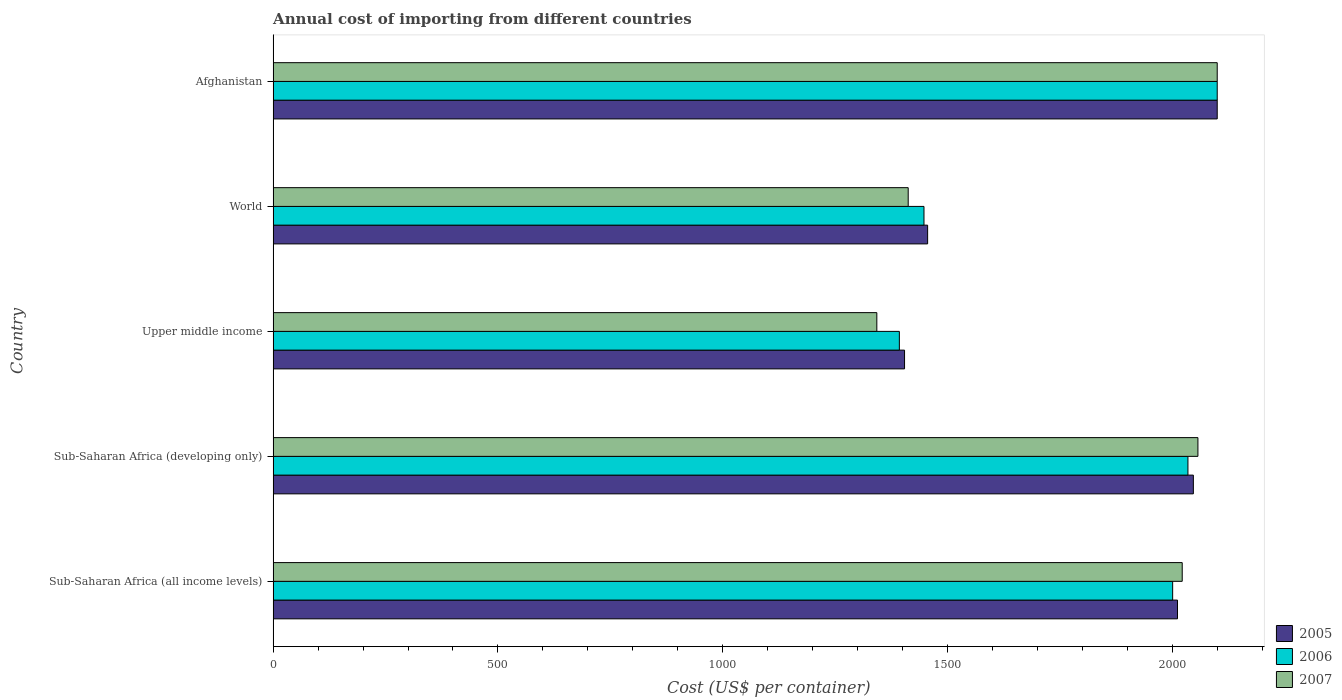How many different coloured bars are there?
Provide a short and direct response. 3. How many bars are there on the 2nd tick from the bottom?
Give a very brief answer. 3. What is the label of the 5th group of bars from the top?
Your answer should be compact. Sub-Saharan Africa (all income levels). In how many cases, is the number of bars for a given country not equal to the number of legend labels?
Keep it short and to the point. 0. What is the total annual cost of importing in 2006 in Sub-Saharan Africa (all income levels)?
Give a very brief answer. 2000.87. Across all countries, what is the maximum total annual cost of importing in 2006?
Make the answer very short. 2100. Across all countries, what is the minimum total annual cost of importing in 2007?
Offer a terse response. 1342.85. In which country was the total annual cost of importing in 2006 maximum?
Your answer should be compact. Afghanistan. In which country was the total annual cost of importing in 2006 minimum?
Offer a terse response. Upper middle income. What is the total total annual cost of importing in 2007 in the graph?
Give a very brief answer. 8934.67. What is the difference between the total annual cost of importing in 2005 in Sub-Saharan Africa (developing only) and that in Upper middle income?
Give a very brief answer. 642.4. What is the difference between the total annual cost of importing in 2006 in Sub-Saharan Africa (developing only) and the total annual cost of importing in 2005 in Sub-Saharan Africa (all income levels)?
Make the answer very short. 23.2. What is the average total annual cost of importing in 2006 per country?
Ensure brevity in your answer.  1795.28. What is the difference between the total annual cost of importing in 2007 and total annual cost of importing in 2006 in Sub-Saharan Africa (all income levels)?
Offer a very short reply. 21.26. What is the ratio of the total annual cost of importing in 2006 in Afghanistan to that in World?
Your answer should be compact. 1.45. What is the difference between the highest and the second highest total annual cost of importing in 2007?
Keep it short and to the point. 42.93. What is the difference between the highest and the lowest total annual cost of importing in 2005?
Offer a terse response. 695.49. Is the sum of the total annual cost of importing in 2006 in Sub-Saharan Africa (developing only) and Upper middle income greater than the maximum total annual cost of importing in 2007 across all countries?
Offer a terse response. Yes. Is it the case that in every country, the sum of the total annual cost of importing in 2007 and total annual cost of importing in 2006 is greater than the total annual cost of importing in 2005?
Provide a succinct answer. Yes. Are all the bars in the graph horizontal?
Provide a succinct answer. Yes. How many countries are there in the graph?
Offer a terse response. 5. Does the graph contain any zero values?
Offer a very short reply. No. Does the graph contain grids?
Provide a succinct answer. No. How many legend labels are there?
Your response must be concise. 3. What is the title of the graph?
Your answer should be very brief. Annual cost of importing from different countries. Does "2002" appear as one of the legend labels in the graph?
Provide a succinct answer. No. What is the label or title of the X-axis?
Give a very brief answer. Cost (US$ per container). What is the Cost (US$ per container) of 2005 in Sub-Saharan Africa (all income levels)?
Keep it short and to the point. 2011.64. What is the Cost (US$ per container) of 2006 in Sub-Saharan Africa (all income levels)?
Provide a succinct answer. 2000.87. What is the Cost (US$ per container) in 2007 in Sub-Saharan Africa (all income levels)?
Make the answer very short. 2022.13. What is the Cost (US$ per container) in 2005 in Sub-Saharan Africa (developing only)?
Your answer should be compact. 2046.91. What is the Cost (US$ per container) in 2006 in Sub-Saharan Africa (developing only)?
Provide a succinct answer. 2034.84. What is the Cost (US$ per container) of 2007 in Sub-Saharan Africa (developing only)?
Provide a short and direct response. 2057.07. What is the Cost (US$ per container) in 2005 in Upper middle income?
Your answer should be compact. 1404.51. What is the Cost (US$ per container) of 2006 in Upper middle income?
Ensure brevity in your answer.  1392.96. What is the Cost (US$ per container) of 2007 in Upper middle income?
Offer a terse response. 1342.85. What is the Cost (US$ per container) in 2005 in World?
Your answer should be compact. 1455.85. What is the Cost (US$ per container) of 2006 in World?
Provide a short and direct response. 1447.74. What is the Cost (US$ per container) of 2007 in World?
Make the answer very short. 1412.62. What is the Cost (US$ per container) of 2005 in Afghanistan?
Offer a very short reply. 2100. What is the Cost (US$ per container) in 2006 in Afghanistan?
Provide a short and direct response. 2100. What is the Cost (US$ per container) of 2007 in Afghanistan?
Provide a short and direct response. 2100. Across all countries, what is the maximum Cost (US$ per container) of 2005?
Make the answer very short. 2100. Across all countries, what is the maximum Cost (US$ per container) in 2006?
Make the answer very short. 2100. Across all countries, what is the maximum Cost (US$ per container) in 2007?
Keep it short and to the point. 2100. Across all countries, what is the minimum Cost (US$ per container) in 2005?
Offer a very short reply. 1404.51. Across all countries, what is the minimum Cost (US$ per container) of 2006?
Ensure brevity in your answer.  1392.96. Across all countries, what is the minimum Cost (US$ per container) of 2007?
Ensure brevity in your answer.  1342.85. What is the total Cost (US$ per container) of 2005 in the graph?
Make the answer very short. 9018.91. What is the total Cost (US$ per container) of 2006 in the graph?
Your answer should be very brief. 8976.41. What is the total Cost (US$ per container) of 2007 in the graph?
Ensure brevity in your answer.  8934.67. What is the difference between the Cost (US$ per container) of 2005 in Sub-Saharan Africa (all income levels) and that in Sub-Saharan Africa (developing only)?
Your response must be concise. -35.26. What is the difference between the Cost (US$ per container) of 2006 in Sub-Saharan Africa (all income levels) and that in Sub-Saharan Africa (developing only)?
Your answer should be very brief. -33.97. What is the difference between the Cost (US$ per container) in 2007 in Sub-Saharan Africa (all income levels) and that in Sub-Saharan Africa (developing only)?
Your response must be concise. -34.94. What is the difference between the Cost (US$ per container) in 2005 in Sub-Saharan Africa (all income levels) and that in Upper middle income?
Provide a succinct answer. 607.13. What is the difference between the Cost (US$ per container) in 2006 in Sub-Saharan Africa (all income levels) and that in Upper middle income?
Provide a succinct answer. 607.91. What is the difference between the Cost (US$ per container) of 2007 in Sub-Saharan Africa (all income levels) and that in Upper middle income?
Make the answer very short. 679.28. What is the difference between the Cost (US$ per container) in 2005 in Sub-Saharan Africa (all income levels) and that in World?
Your response must be concise. 555.79. What is the difference between the Cost (US$ per container) of 2006 in Sub-Saharan Africa (all income levels) and that in World?
Your answer should be compact. 553.13. What is the difference between the Cost (US$ per container) of 2007 in Sub-Saharan Africa (all income levels) and that in World?
Your answer should be compact. 609.51. What is the difference between the Cost (US$ per container) in 2005 in Sub-Saharan Africa (all income levels) and that in Afghanistan?
Give a very brief answer. -88.36. What is the difference between the Cost (US$ per container) of 2006 in Sub-Saharan Africa (all income levels) and that in Afghanistan?
Offer a terse response. -99.13. What is the difference between the Cost (US$ per container) in 2007 in Sub-Saharan Africa (all income levels) and that in Afghanistan?
Keep it short and to the point. -77.87. What is the difference between the Cost (US$ per container) of 2005 in Sub-Saharan Africa (developing only) and that in Upper middle income?
Keep it short and to the point. 642.4. What is the difference between the Cost (US$ per container) of 2006 in Sub-Saharan Africa (developing only) and that in Upper middle income?
Offer a terse response. 641.88. What is the difference between the Cost (US$ per container) of 2007 in Sub-Saharan Africa (developing only) and that in Upper middle income?
Keep it short and to the point. 714.21. What is the difference between the Cost (US$ per container) in 2005 in Sub-Saharan Africa (developing only) and that in World?
Provide a short and direct response. 591.06. What is the difference between the Cost (US$ per container) of 2006 in Sub-Saharan Africa (developing only) and that in World?
Keep it short and to the point. 587.1. What is the difference between the Cost (US$ per container) of 2007 in Sub-Saharan Africa (developing only) and that in World?
Offer a very short reply. 644.45. What is the difference between the Cost (US$ per container) of 2005 in Sub-Saharan Africa (developing only) and that in Afghanistan?
Offer a terse response. -53.09. What is the difference between the Cost (US$ per container) in 2006 in Sub-Saharan Africa (developing only) and that in Afghanistan?
Keep it short and to the point. -65.16. What is the difference between the Cost (US$ per container) of 2007 in Sub-Saharan Africa (developing only) and that in Afghanistan?
Offer a terse response. -42.93. What is the difference between the Cost (US$ per container) in 2005 in Upper middle income and that in World?
Ensure brevity in your answer.  -51.34. What is the difference between the Cost (US$ per container) in 2006 in Upper middle income and that in World?
Your answer should be very brief. -54.78. What is the difference between the Cost (US$ per container) of 2007 in Upper middle income and that in World?
Make the answer very short. -69.76. What is the difference between the Cost (US$ per container) of 2005 in Upper middle income and that in Afghanistan?
Offer a very short reply. -695.49. What is the difference between the Cost (US$ per container) in 2006 in Upper middle income and that in Afghanistan?
Offer a very short reply. -707.04. What is the difference between the Cost (US$ per container) in 2007 in Upper middle income and that in Afghanistan?
Your answer should be very brief. -757.15. What is the difference between the Cost (US$ per container) in 2005 in World and that in Afghanistan?
Your answer should be compact. -644.15. What is the difference between the Cost (US$ per container) of 2006 in World and that in Afghanistan?
Provide a short and direct response. -652.26. What is the difference between the Cost (US$ per container) of 2007 in World and that in Afghanistan?
Ensure brevity in your answer.  -687.38. What is the difference between the Cost (US$ per container) of 2005 in Sub-Saharan Africa (all income levels) and the Cost (US$ per container) of 2006 in Sub-Saharan Africa (developing only)?
Your answer should be very brief. -23.2. What is the difference between the Cost (US$ per container) of 2005 in Sub-Saharan Africa (all income levels) and the Cost (US$ per container) of 2007 in Sub-Saharan Africa (developing only)?
Your answer should be compact. -45.42. What is the difference between the Cost (US$ per container) in 2006 in Sub-Saharan Africa (all income levels) and the Cost (US$ per container) in 2007 in Sub-Saharan Africa (developing only)?
Offer a terse response. -56.2. What is the difference between the Cost (US$ per container) in 2005 in Sub-Saharan Africa (all income levels) and the Cost (US$ per container) in 2006 in Upper middle income?
Your answer should be compact. 618.69. What is the difference between the Cost (US$ per container) of 2005 in Sub-Saharan Africa (all income levels) and the Cost (US$ per container) of 2007 in Upper middle income?
Keep it short and to the point. 668.79. What is the difference between the Cost (US$ per container) in 2006 in Sub-Saharan Africa (all income levels) and the Cost (US$ per container) in 2007 in Upper middle income?
Give a very brief answer. 658.02. What is the difference between the Cost (US$ per container) in 2005 in Sub-Saharan Africa (all income levels) and the Cost (US$ per container) in 2006 in World?
Keep it short and to the point. 563.9. What is the difference between the Cost (US$ per container) in 2005 in Sub-Saharan Africa (all income levels) and the Cost (US$ per container) in 2007 in World?
Offer a very short reply. 599.03. What is the difference between the Cost (US$ per container) of 2006 in Sub-Saharan Africa (all income levels) and the Cost (US$ per container) of 2007 in World?
Your answer should be very brief. 588.25. What is the difference between the Cost (US$ per container) of 2005 in Sub-Saharan Africa (all income levels) and the Cost (US$ per container) of 2006 in Afghanistan?
Make the answer very short. -88.36. What is the difference between the Cost (US$ per container) in 2005 in Sub-Saharan Africa (all income levels) and the Cost (US$ per container) in 2007 in Afghanistan?
Give a very brief answer. -88.36. What is the difference between the Cost (US$ per container) of 2006 in Sub-Saharan Africa (all income levels) and the Cost (US$ per container) of 2007 in Afghanistan?
Provide a short and direct response. -99.13. What is the difference between the Cost (US$ per container) of 2005 in Sub-Saharan Africa (developing only) and the Cost (US$ per container) of 2006 in Upper middle income?
Your response must be concise. 653.95. What is the difference between the Cost (US$ per container) in 2005 in Sub-Saharan Africa (developing only) and the Cost (US$ per container) in 2007 in Upper middle income?
Keep it short and to the point. 704.05. What is the difference between the Cost (US$ per container) in 2006 in Sub-Saharan Africa (developing only) and the Cost (US$ per container) in 2007 in Upper middle income?
Provide a short and direct response. 691.99. What is the difference between the Cost (US$ per container) in 2005 in Sub-Saharan Africa (developing only) and the Cost (US$ per container) in 2006 in World?
Ensure brevity in your answer.  599.17. What is the difference between the Cost (US$ per container) of 2005 in Sub-Saharan Africa (developing only) and the Cost (US$ per container) of 2007 in World?
Make the answer very short. 634.29. What is the difference between the Cost (US$ per container) of 2006 in Sub-Saharan Africa (developing only) and the Cost (US$ per container) of 2007 in World?
Give a very brief answer. 622.22. What is the difference between the Cost (US$ per container) in 2005 in Sub-Saharan Africa (developing only) and the Cost (US$ per container) in 2006 in Afghanistan?
Your answer should be compact. -53.09. What is the difference between the Cost (US$ per container) in 2005 in Sub-Saharan Africa (developing only) and the Cost (US$ per container) in 2007 in Afghanistan?
Make the answer very short. -53.09. What is the difference between the Cost (US$ per container) of 2006 in Sub-Saharan Africa (developing only) and the Cost (US$ per container) of 2007 in Afghanistan?
Provide a short and direct response. -65.16. What is the difference between the Cost (US$ per container) of 2005 in Upper middle income and the Cost (US$ per container) of 2006 in World?
Your answer should be very brief. -43.23. What is the difference between the Cost (US$ per container) of 2005 in Upper middle income and the Cost (US$ per container) of 2007 in World?
Give a very brief answer. -8.11. What is the difference between the Cost (US$ per container) in 2006 in Upper middle income and the Cost (US$ per container) in 2007 in World?
Offer a terse response. -19.66. What is the difference between the Cost (US$ per container) of 2005 in Upper middle income and the Cost (US$ per container) of 2006 in Afghanistan?
Provide a short and direct response. -695.49. What is the difference between the Cost (US$ per container) of 2005 in Upper middle income and the Cost (US$ per container) of 2007 in Afghanistan?
Give a very brief answer. -695.49. What is the difference between the Cost (US$ per container) of 2006 in Upper middle income and the Cost (US$ per container) of 2007 in Afghanistan?
Make the answer very short. -707.04. What is the difference between the Cost (US$ per container) in 2005 in World and the Cost (US$ per container) in 2006 in Afghanistan?
Make the answer very short. -644.15. What is the difference between the Cost (US$ per container) in 2005 in World and the Cost (US$ per container) in 2007 in Afghanistan?
Provide a succinct answer. -644.15. What is the difference between the Cost (US$ per container) in 2006 in World and the Cost (US$ per container) in 2007 in Afghanistan?
Provide a short and direct response. -652.26. What is the average Cost (US$ per container) of 2005 per country?
Provide a short and direct response. 1803.78. What is the average Cost (US$ per container) in 2006 per country?
Keep it short and to the point. 1795.28. What is the average Cost (US$ per container) of 2007 per country?
Offer a very short reply. 1786.93. What is the difference between the Cost (US$ per container) of 2005 and Cost (US$ per container) of 2006 in Sub-Saharan Africa (all income levels)?
Give a very brief answer. 10.77. What is the difference between the Cost (US$ per container) in 2005 and Cost (US$ per container) in 2007 in Sub-Saharan Africa (all income levels)?
Keep it short and to the point. -10.49. What is the difference between the Cost (US$ per container) in 2006 and Cost (US$ per container) in 2007 in Sub-Saharan Africa (all income levels)?
Provide a short and direct response. -21.26. What is the difference between the Cost (US$ per container) of 2005 and Cost (US$ per container) of 2006 in Sub-Saharan Africa (developing only)?
Give a very brief answer. 12.07. What is the difference between the Cost (US$ per container) of 2005 and Cost (US$ per container) of 2007 in Sub-Saharan Africa (developing only)?
Make the answer very short. -10.16. What is the difference between the Cost (US$ per container) of 2006 and Cost (US$ per container) of 2007 in Sub-Saharan Africa (developing only)?
Your answer should be compact. -22.23. What is the difference between the Cost (US$ per container) in 2005 and Cost (US$ per container) in 2006 in Upper middle income?
Your answer should be compact. 11.55. What is the difference between the Cost (US$ per container) of 2005 and Cost (US$ per container) of 2007 in Upper middle income?
Provide a short and direct response. 61.66. What is the difference between the Cost (US$ per container) of 2006 and Cost (US$ per container) of 2007 in Upper middle income?
Offer a terse response. 50.1. What is the difference between the Cost (US$ per container) of 2005 and Cost (US$ per container) of 2006 in World?
Ensure brevity in your answer.  8.11. What is the difference between the Cost (US$ per container) of 2005 and Cost (US$ per container) of 2007 in World?
Your answer should be compact. 43.23. What is the difference between the Cost (US$ per container) in 2006 and Cost (US$ per container) in 2007 in World?
Your answer should be very brief. 35.12. What is the ratio of the Cost (US$ per container) in 2005 in Sub-Saharan Africa (all income levels) to that in Sub-Saharan Africa (developing only)?
Offer a very short reply. 0.98. What is the ratio of the Cost (US$ per container) in 2006 in Sub-Saharan Africa (all income levels) to that in Sub-Saharan Africa (developing only)?
Your answer should be very brief. 0.98. What is the ratio of the Cost (US$ per container) in 2005 in Sub-Saharan Africa (all income levels) to that in Upper middle income?
Offer a terse response. 1.43. What is the ratio of the Cost (US$ per container) in 2006 in Sub-Saharan Africa (all income levels) to that in Upper middle income?
Ensure brevity in your answer.  1.44. What is the ratio of the Cost (US$ per container) of 2007 in Sub-Saharan Africa (all income levels) to that in Upper middle income?
Your answer should be compact. 1.51. What is the ratio of the Cost (US$ per container) in 2005 in Sub-Saharan Africa (all income levels) to that in World?
Your response must be concise. 1.38. What is the ratio of the Cost (US$ per container) in 2006 in Sub-Saharan Africa (all income levels) to that in World?
Your answer should be very brief. 1.38. What is the ratio of the Cost (US$ per container) of 2007 in Sub-Saharan Africa (all income levels) to that in World?
Offer a terse response. 1.43. What is the ratio of the Cost (US$ per container) in 2005 in Sub-Saharan Africa (all income levels) to that in Afghanistan?
Give a very brief answer. 0.96. What is the ratio of the Cost (US$ per container) of 2006 in Sub-Saharan Africa (all income levels) to that in Afghanistan?
Your response must be concise. 0.95. What is the ratio of the Cost (US$ per container) of 2007 in Sub-Saharan Africa (all income levels) to that in Afghanistan?
Give a very brief answer. 0.96. What is the ratio of the Cost (US$ per container) in 2005 in Sub-Saharan Africa (developing only) to that in Upper middle income?
Your answer should be very brief. 1.46. What is the ratio of the Cost (US$ per container) of 2006 in Sub-Saharan Africa (developing only) to that in Upper middle income?
Your answer should be very brief. 1.46. What is the ratio of the Cost (US$ per container) in 2007 in Sub-Saharan Africa (developing only) to that in Upper middle income?
Ensure brevity in your answer.  1.53. What is the ratio of the Cost (US$ per container) in 2005 in Sub-Saharan Africa (developing only) to that in World?
Provide a succinct answer. 1.41. What is the ratio of the Cost (US$ per container) of 2006 in Sub-Saharan Africa (developing only) to that in World?
Make the answer very short. 1.41. What is the ratio of the Cost (US$ per container) of 2007 in Sub-Saharan Africa (developing only) to that in World?
Keep it short and to the point. 1.46. What is the ratio of the Cost (US$ per container) of 2005 in Sub-Saharan Africa (developing only) to that in Afghanistan?
Make the answer very short. 0.97. What is the ratio of the Cost (US$ per container) in 2006 in Sub-Saharan Africa (developing only) to that in Afghanistan?
Your answer should be very brief. 0.97. What is the ratio of the Cost (US$ per container) of 2007 in Sub-Saharan Africa (developing only) to that in Afghanistan?
Make the answer very short. 0.98. What is the ratio of the Cost (US$ per container) of 2005 in Upper middle income to that in World?
Offer a very short reply. 0.96. What is the ratio of the Cost (US$ per container) of 2006 in Upper middle income to that in World?
Your response must be concise. 0.96. What is the ratio of the Cost (US$ per container) of 2007 in Upper middle income to that in World?
Provide a succinct answer. 0.95. What is the ratio of the Cost (US$ per container) of 2005 in Upper middle income to that in Afghanistan?
Provide a short and direct response. 0.67. What is the ratio of the Cost (US$ per container) in 2006 in Upper middle income to that in Afghanistan?
Keep it short and to the point. 0.66. What is the ratio of the Cost (US$ per container) of 2007 in Upper middle income to that in Afghanistan?
Your answer should be compact. 0.64. What is the ratio of the Cost (US$ per container) of 2005 in World to that in Afghanistan?
Your response must be concise. 0.69. What is the ratio of the Cost (US$ per container) of 2006 in World to that in Afghanistan?
Give a very brief answer. 0.69. What is the ratio of the Cost (US$ per container) in 2007 in World to that in Afghanistan?
Your answer should be compact. 0.67. What is the difference between the highest and the second highest Cost (US$ per container) in 2005?
Your response must be concise. 53.09. What is the difference between the highest and the second highest Cost (US$ per container) of 2006?
Give a very brief answer. 65.16. What is the difference between the highest and the second highest Cost (US$ per container) in 2007?
Ensure brevity in your answer.  42.93. What is the difference between the highest and the lowest Cost (US$ per container) in 2005?
Provide a short and direct response. 695.49. What is the difference between the highest and the lowest Cost (US$ per container) of 2006?
Provide a succinct answer. 707.04. What is the difference between the highest and the lowest Cost (US$ per container) of 2007?
Provide a short and direct response. 757.15. 